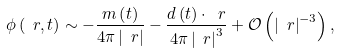<formula> <loc_0><loc_0><loc_500><loc_500>\phi \left ( \ r , t \right ) \sim - \frac { m \left ( t \right ) } { 4 \pi \left | \ r \right | } - \frac { d \left ( t \right ) \cdot \ r } { 4 \pi \left | \ r \right | ^ { 3 } } + \mathcal { O } \left ( \left | \ r \right | ^ { - 3 } \right ) ,</formula> 